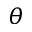Convert formula to latex. <formula><loc_0><loc_0><loc_500><loc_500>\theta</formula> 